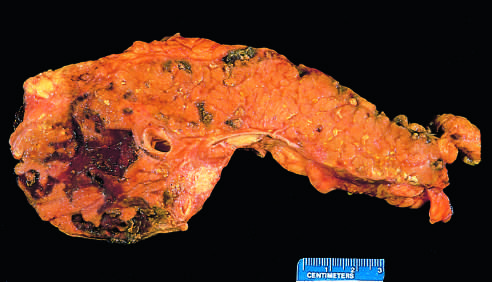how has the pancreas been sectioned?
Answer the question using a single word or phrase. Longitudinally 